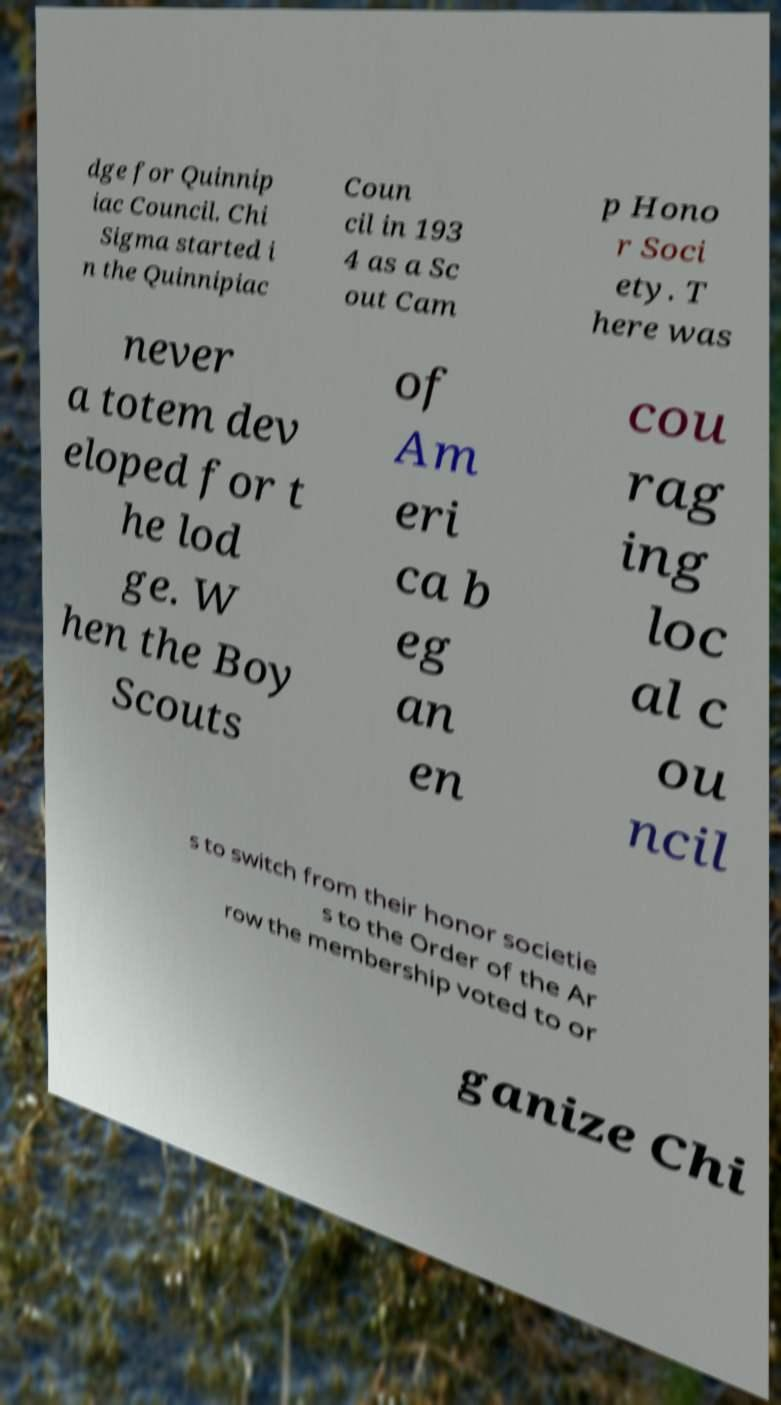Can you accurately transcribe the text from the provided image for me? dge for Quinnip iac Council. Chi Sigma started i n the Quinnipiac Coun cil in 193 4 as a Sc out Cam p Hono r Soci ety. T here was never a totem dev eloped for t he lod ge. W hen the Boy Scouts of Am eri ca b eg an en cou rag ing loc al c ou ncil s to switch from their honor societie s to the Order of the Ar row the membership voted to or ganize Chi 